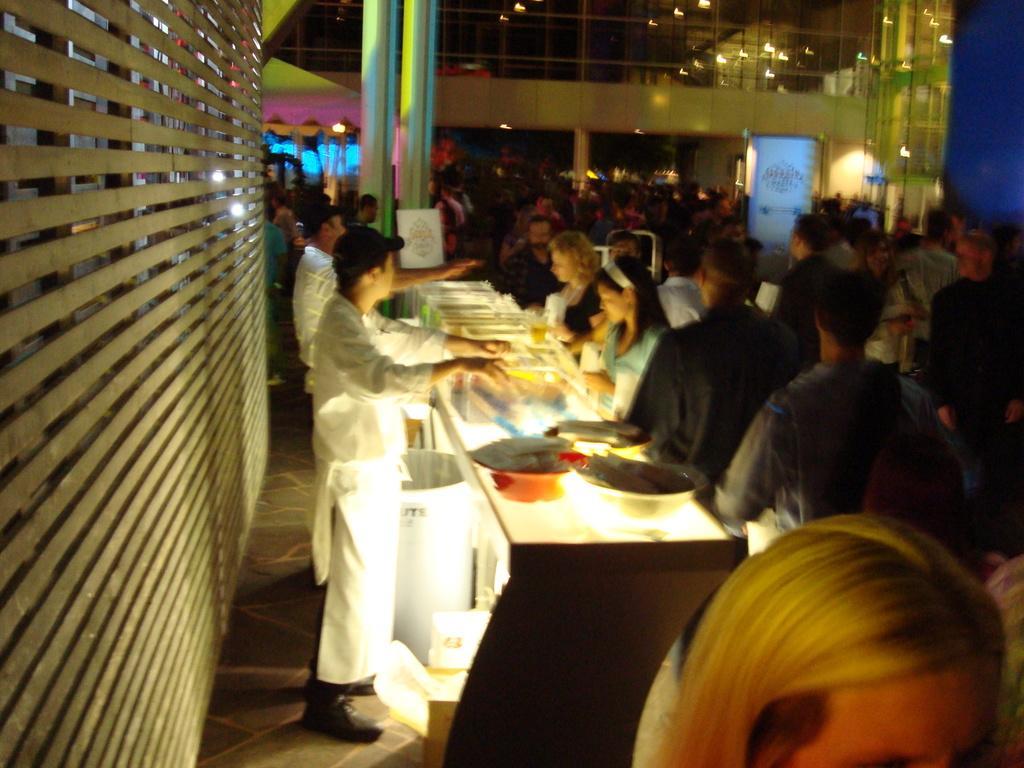Describe this image in one or two sentences. This image consists of so many people, lights on the top and there is a table on which there are bowls and people are on both sides of table. There is a pillar in the middle. 